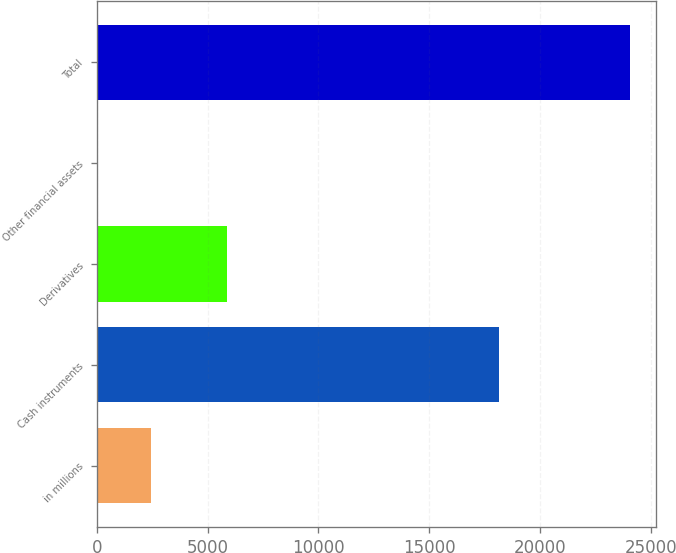Convert chart to OTSL. <chart><loc_0><loc_0><loc_500><loc_500><bar_chart><fcel>in millions<fcel>Cash instruments<fcel>Derivatives<fcel>Other financial assets<fcel>Total<nl><fcel>2445.1<fcel>18131<fcel>5870<fcel>45<fcel>24046<nl></chart> 